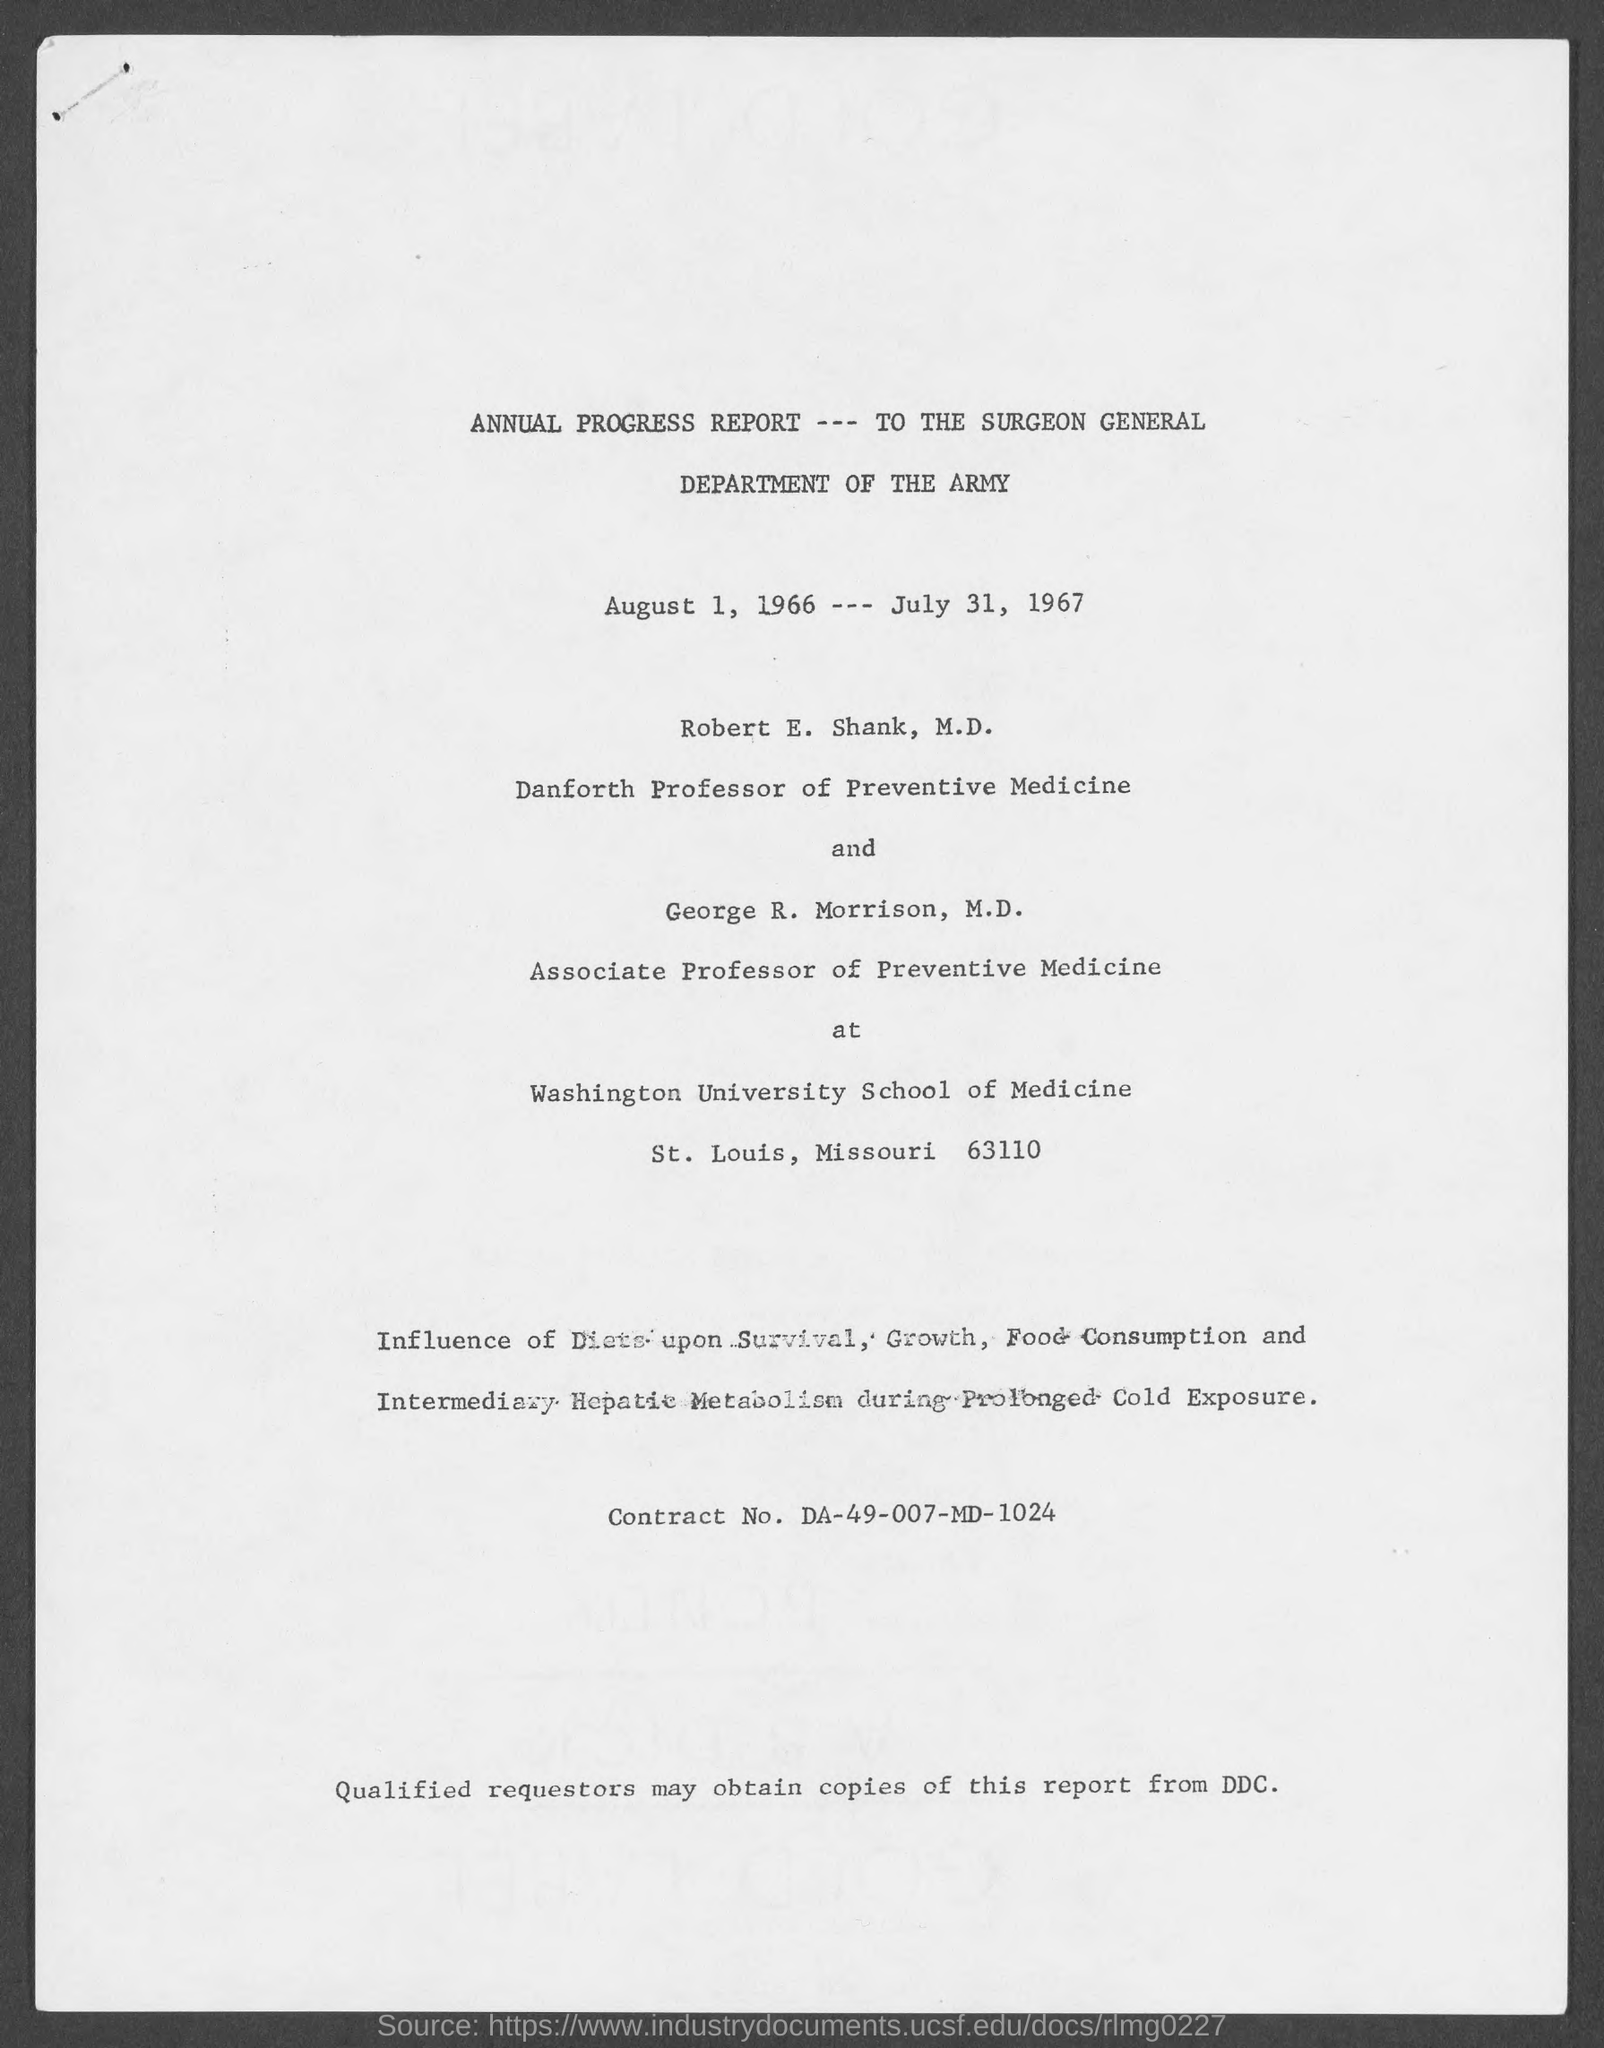In which county is Washington University school of medicine at ?
Make the answer very short. St. Louis. What is the position of robert e. shank, m.d.?
Offer a very short reply. Danforth professor of preventive medicine. What is the contract no.?
Your answer should be compact. DA-49-007-MD-1024. 